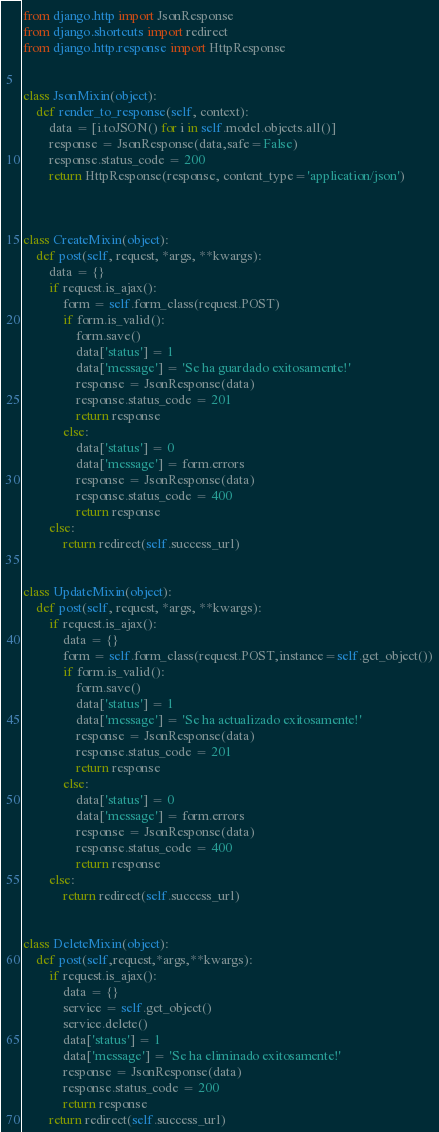Convert code to text. <code><loc_0><loc_0><loc_500><loc_500><_Python_>from django.http import JsonResponse
from django.shortcuts import redirect
from django.http.response import HttpResponse


class JsonMixin(object):
    def render_to_response(self, context):
        data = [i.toJSON() for i in self.model.objects.all()]
        response = JsonResponse(data,safe=False)
        response.status_code = 200
        return HttpResponse(response, content_type='application/json')



class CreateMixin(object):
    def post(self, request, *args, **kwargs):
        data = {}
        if request.is_ajax():
            form = self.form_class(request.POST)
            if form.is_valid():
                form.save()
                data['status'] = 1
                data['message'] = 'Se ha guardado exitosamente!'
                response = JsonResponse(data)
                response.status_code = 201
                return response
            else:
                data['status'] = 0
                data['message'] = form.errors
                response = JsonResponse(data)
                response.status_code = 400
                return response
        else:
            return redirect(self.success_url)


class UpdateMixin(object):
    def post(self, request, *args, **kwargs):
        if request.is_ajax():
            data = {}
            form = self.form_class(request.POST,instance=self.get_object())
            if form.is_valid():
                form.save()
                data['status'] = 1
                data['message'] = 'Se ha actualizado exitosamente!'
                response = JsonResponse(data)
                response.status_code = 201
                return response
            else:
                data['status'] = 0
                data['message'] = form.errors
                response = JsonResponse(data)
                response.status_code = 400
                return response
        else:
            return redirect(self.success_url)


class DeleteMixin(object):
    def post(self,request,*args,**kwargs):
        if request.is_ajax():
            data = {}
            service = self.get_object()
            service.delete()
            data['status'] = 1
            data['message'] = 'Se ha eliminado exitosamente!'
            response = JsonResponse(data)
            response.status_code = 200
            return response
        return redirect(self.success_url)

</code> 